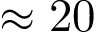Convert formula to latex. <formula><loc_0><loc_0><loc_500><loc_500>\approx 2 0</formula> 